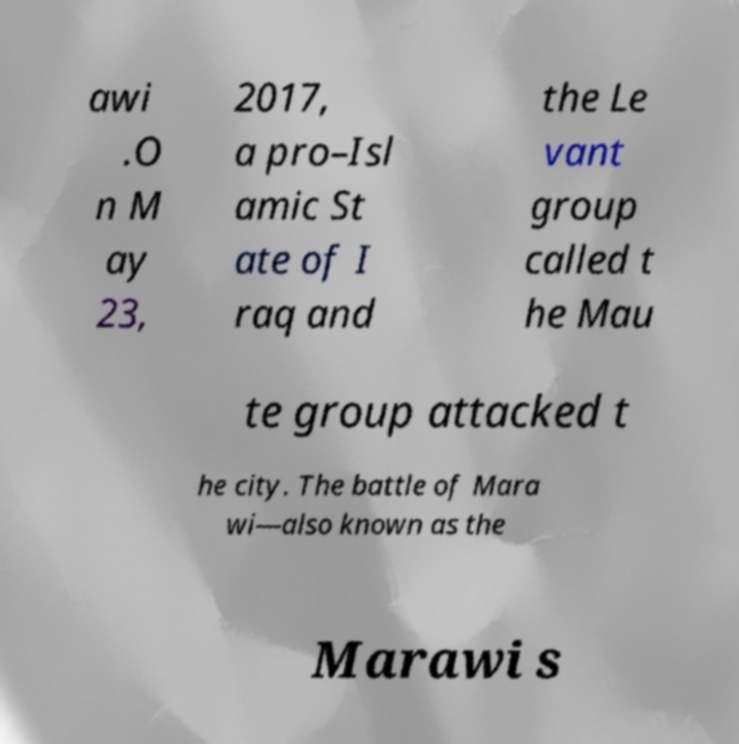I need the written content from this picture converted into text. Can you do that? awi .O n M ay 23, 2017, a pro–Isl amic St ate of I raq and the Le vant group called t he Mau te group attacked t he city. The battle of Mara wi—also known as the Marawi s 